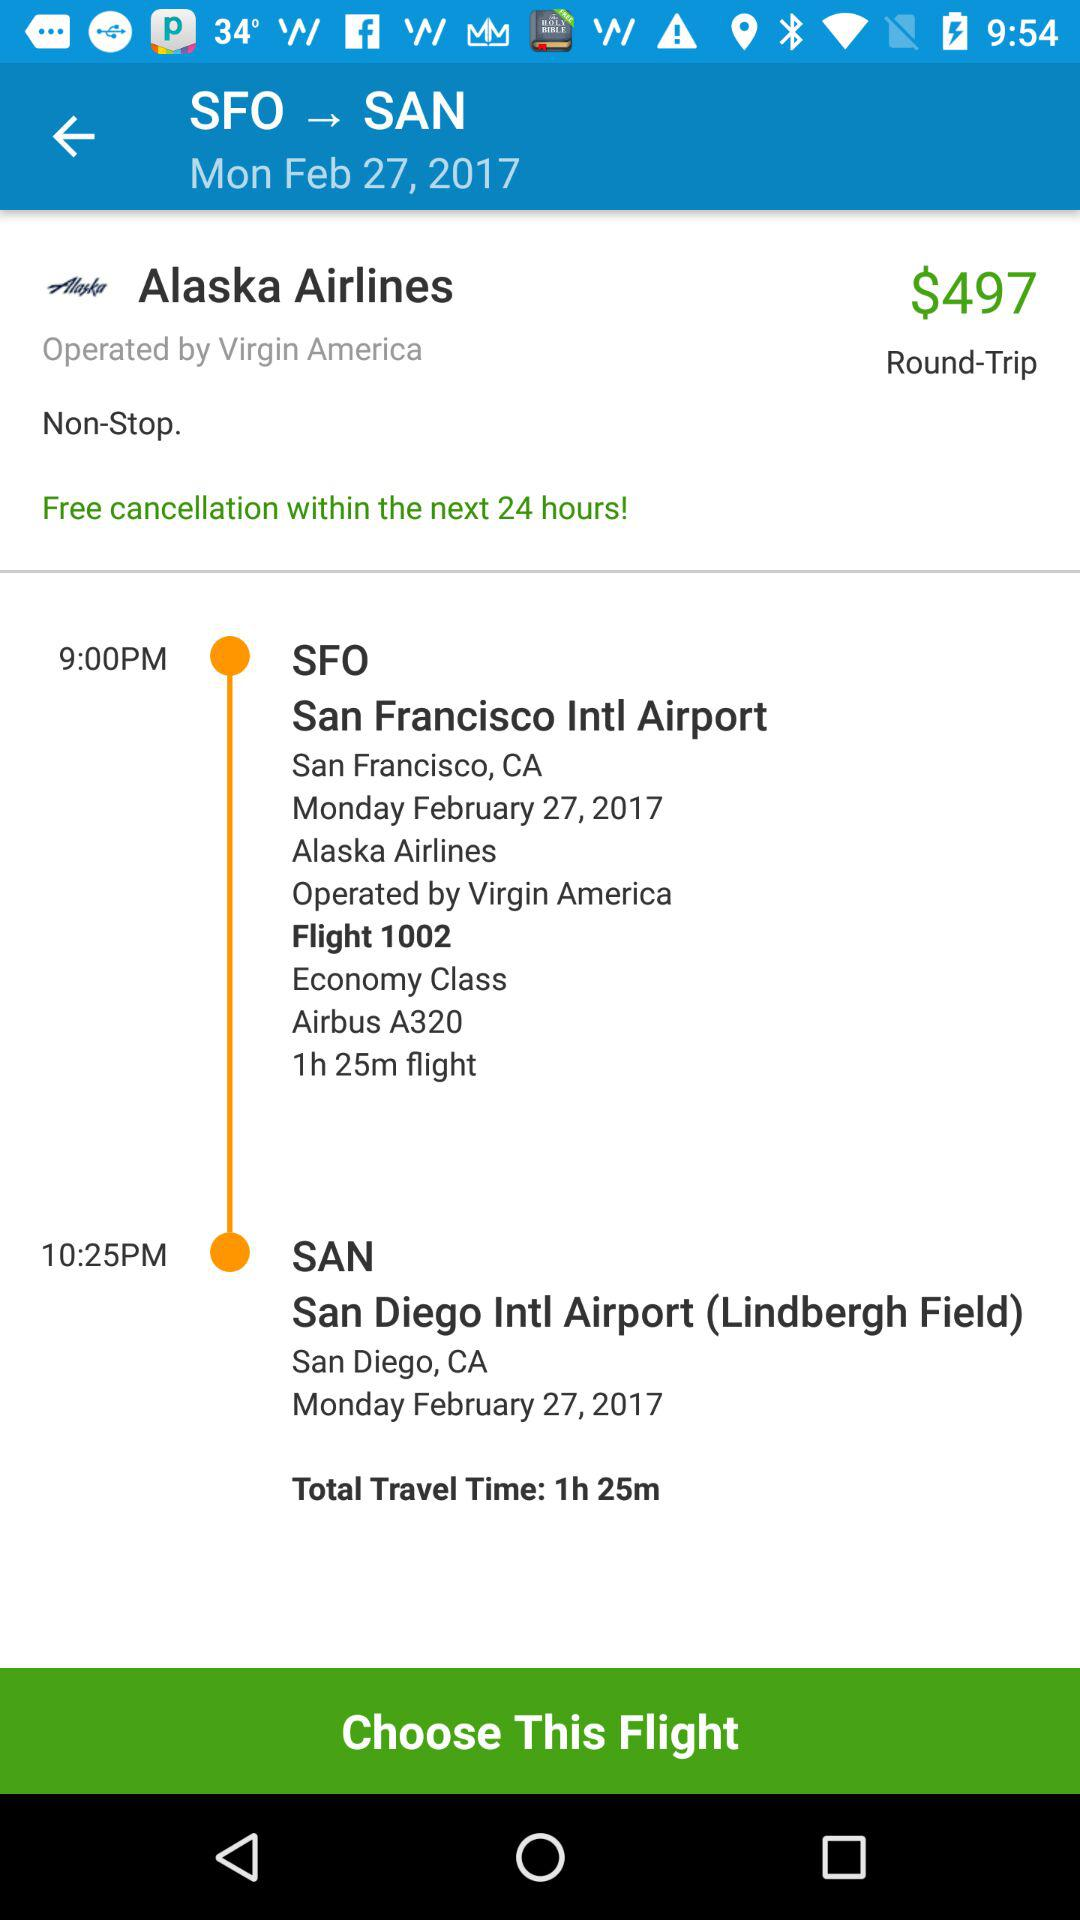Which airline operates Alaska Airlines? It is operated by Virgin America. 